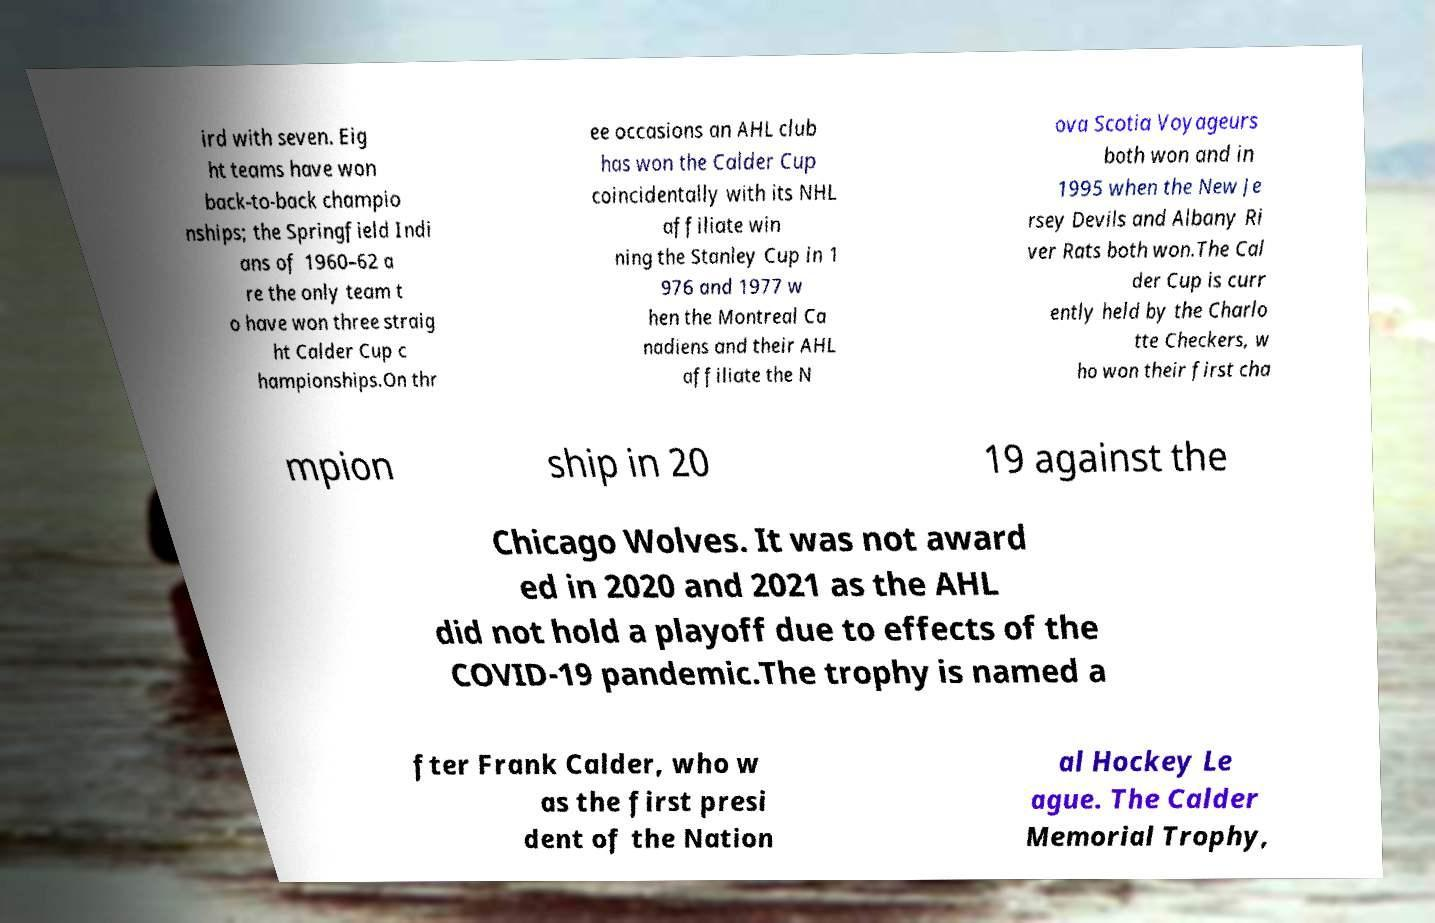Could you extract and type out the text from this image? ird with seven. Eig ht teams have won back-to-back champio nships; the Springfield Indi ans of 1960–62 a re the only team t o have won three straig ht Calder Cup c hampionships.On thr ee occasions an AHL club has won the Calder Cup coincidentally with its NHL affiliate win ning the Stanley Cup in 1 976 and 1977 w hen the Montreal Ca nadiens and their AHL affiliate the N ova Scotia Voyageurs both won and in 1995 when the New Je rsey Devils and Albany Ri ver Rats both won.The Cal der Cup is curr ently held by the Charlo tte Checkers, w ho won their first cha mpion ship in 20 19 against the Chicago Wolves. It was not award ed in 2020 and 2021 as the AHL did not hold a playoff due to effects of the COVID-19 pandemic.The trophy is named a fter Frank Calder, who w as the first presi dent of the Nation al Hockey Le ague. The Calder Memorial Trophy, 